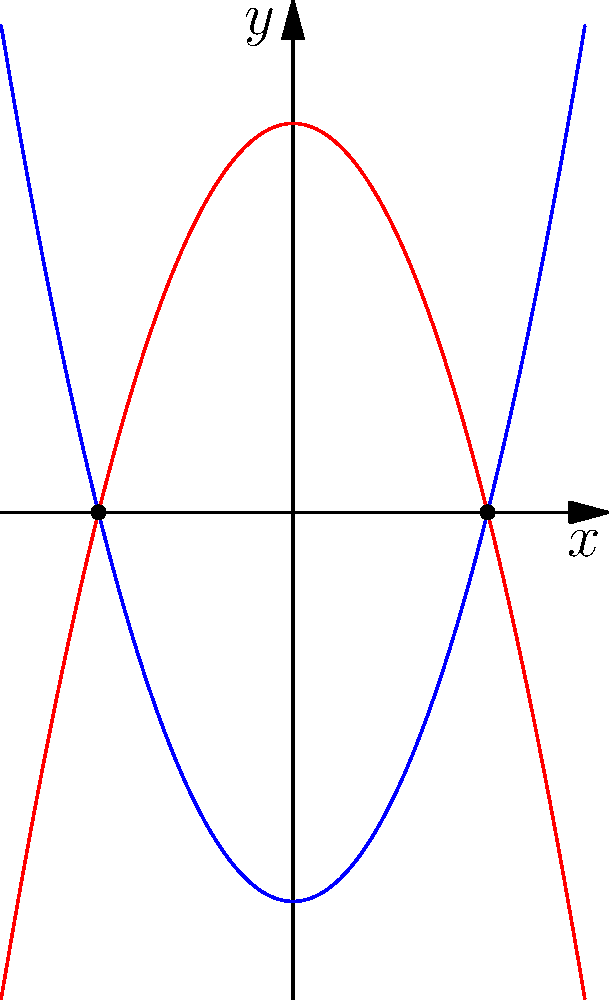As a senior software engineer familiar with VS Code extensions, you're developing a Git workflow visualization tool. You need to implement a function to find intersection points of two curves. Given two parabolas: $y = x^2 - 4$ and $y = -x^2 + 4$, determine their intersection points. To find the intersection points, we need to solve the equation:

$x^2 - 4 = -x^2 + 4$

Step 1: Rearrange the equation
$x^2 + x^2 = 4 + 4$
$2x^2 = 8$

Step 2: Divide both sides by 2
$x^2 = 4$

Step 3: Take the square root of both sides
$x = \pm \sqrt{4} = \pm 2$

Step 4: Calculate the y-coordinate
For $x = 2$: $y = 2^2 - 4 = 0$
For $x = -2$: $y = (-2)^2 - 4 = 0$

Therefore, the intersection points are $(2, 0)$ and $(-2, 0)$.
Answer: $(2, 0)$ and $(-2, 0)$ 